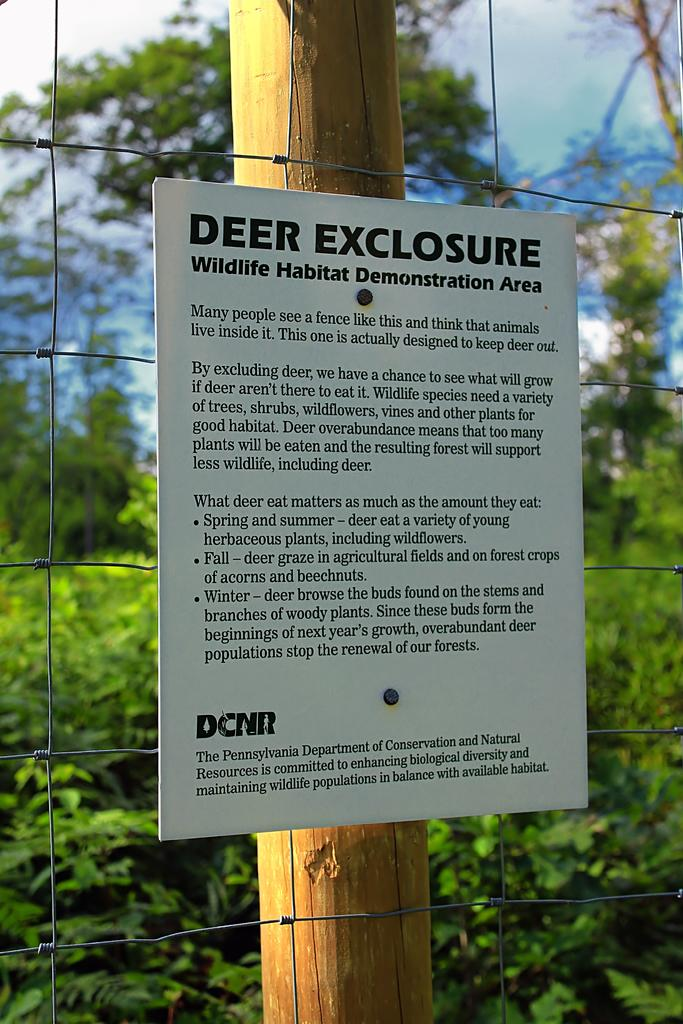What object is attached to a wooden stick in the image? There is a board fixed to a wooden stick in the image. What can be seen in the background of the image? There are plants and trees in the background of the image. What is visible at the top of the image? The sky is visible at the top of the image. What type of yarn is being used to water the plants in the image? There is no yarn or watering activity present in the image. How does the drain in the image affect the plants? There is no drain present in the image. 